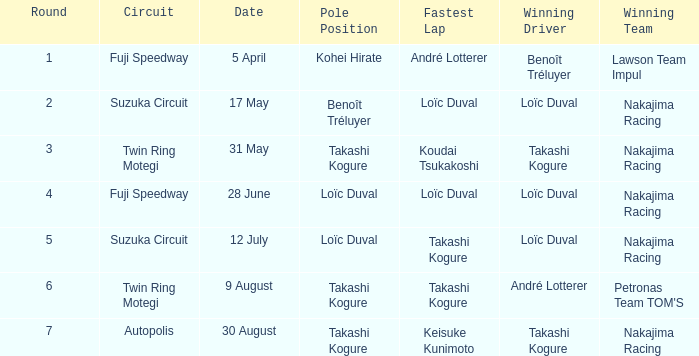In which previous round did takashi kogure achieve the quickest lap? 5.0. 